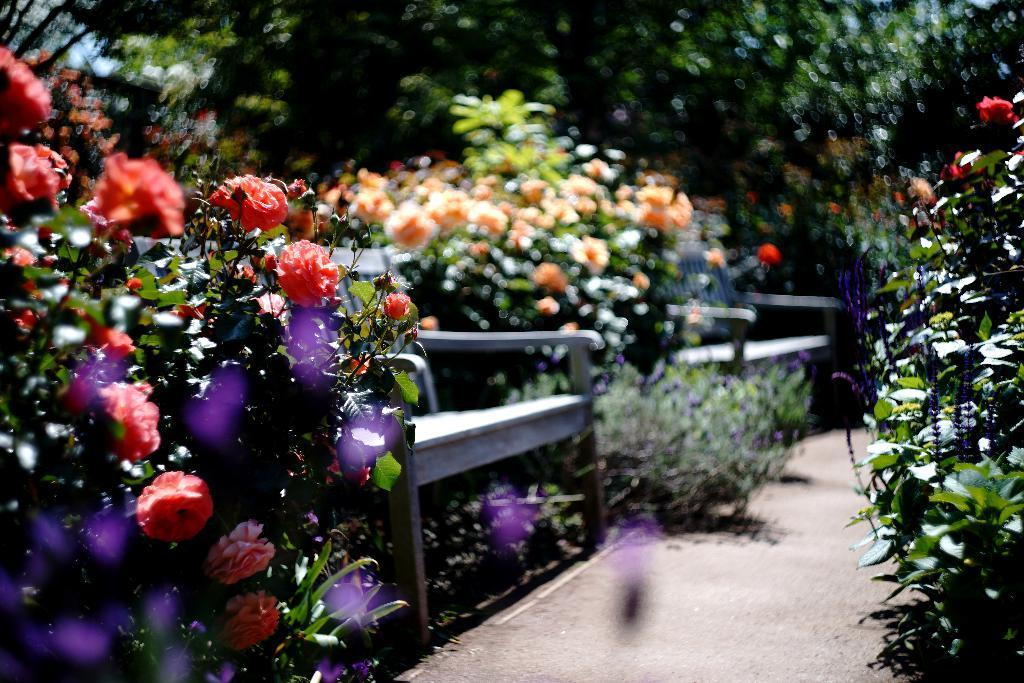What type of vegetation can be seen in the image? There are plants, flowers, and trees in the image. What might people use the benches for in the image? People might use the benches for sitting or resting in the image. What pathway is visible in the image? There is a walkway visible in the image. What type of spade is being used to dig up the flowers in the image? There is no spade or digging activity present in the image. What discovery was made by the person walking on the walkway in the image? There is no person or discovery mentioned in the image. 